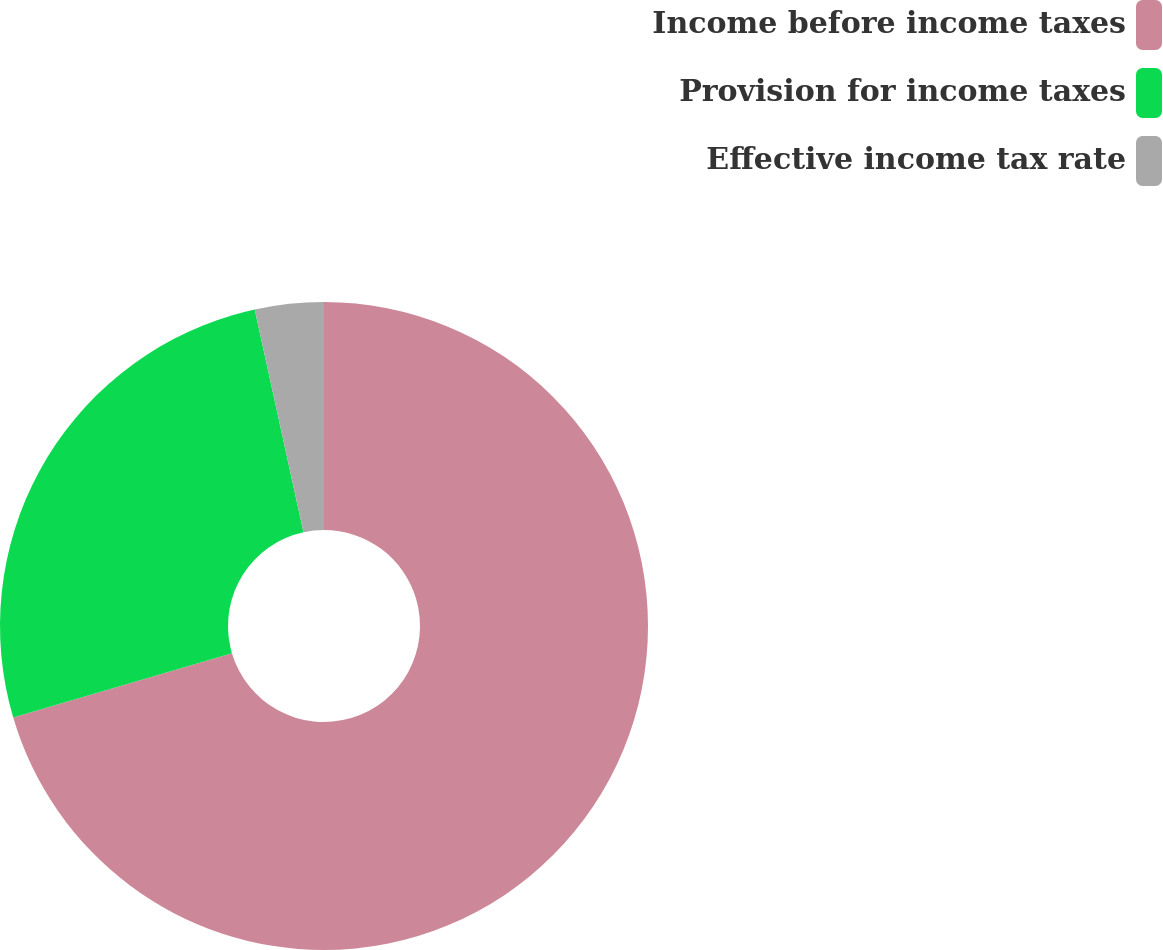Convert chart to OTSL. <chart><loc_0><loc_0><loc_500><loc_500><pie_chart><fcel>Income before income taxes<fcel>Provision for income taxes<fcel>Effective income tax rate<nl><fcel>70.44%<fcel>26.13%<fcel>3.43%<nl></chart> 